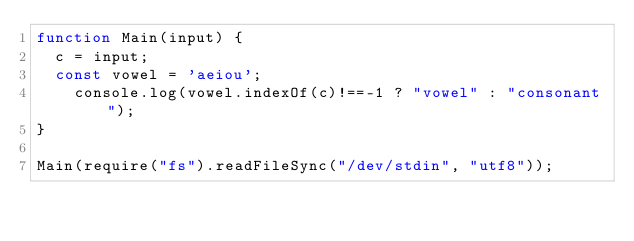<code> <loc_0><loc_0><loc_500><loc_500><_JavaScript_>function Main(input) {
	c = input;
	const vowel = 'aeiou';
  	console.log(vowel.indexOf(c)!==-1 ? "vowel" : "consonant");
}

Main(require("fs").readFileSync("/dev/stdin", "utf8"));</code> 